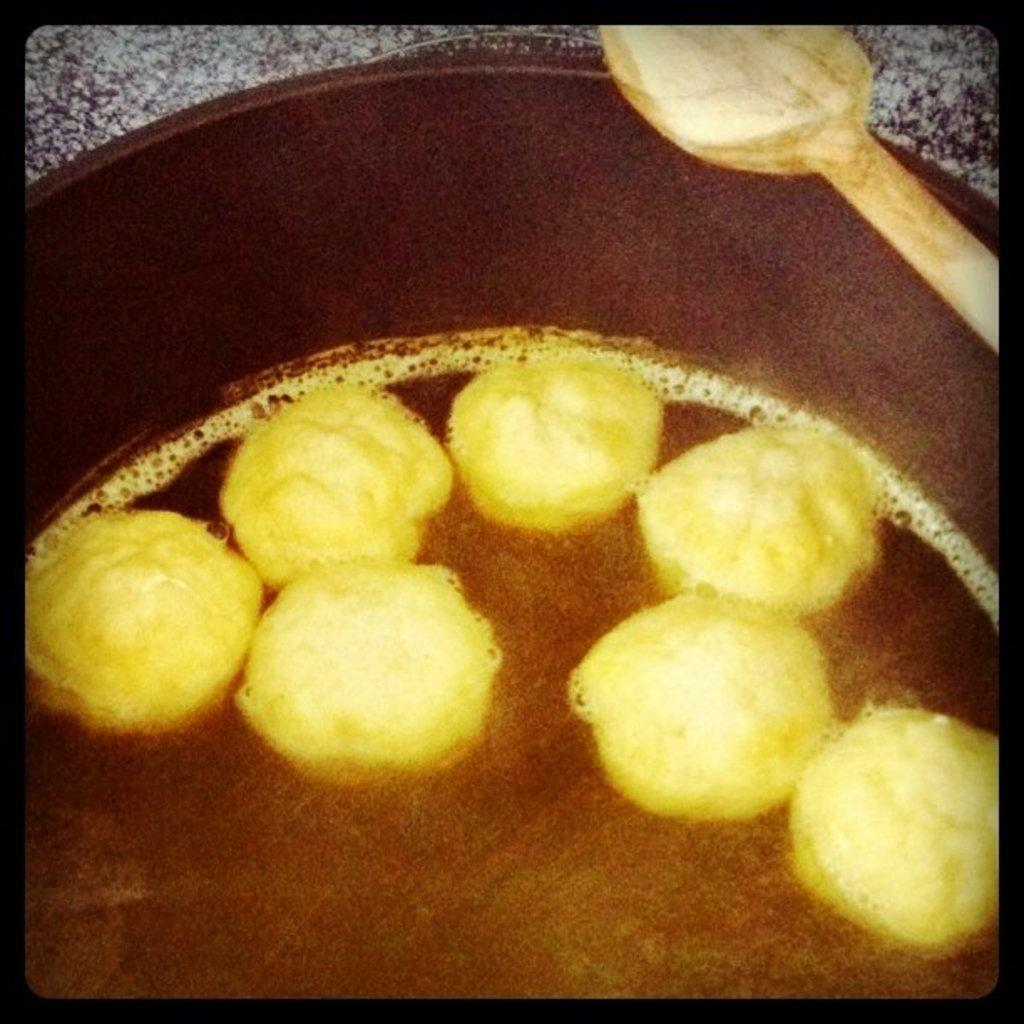What is in the pan that is visible in the image? There is food in the pan in the image. What utensil is visible in the image? There is a serving spoon visible in the image. What type of animal can be seen walking along the coast in the image? There is no animal or coastline present in the image; it only features a pan with food and a serving spoon. 